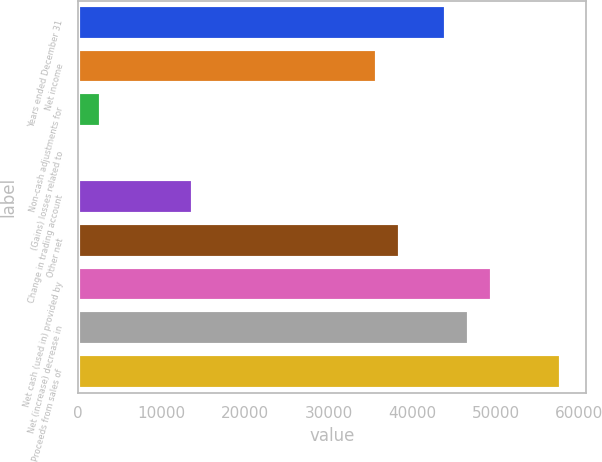Convert chart. <chart><loc_0><loc_0><loc_500><loc_500><bar_chart><fcel>Years ended December 31<fcel>Net income<fcel>Non-cash adjustments for<fcel>(Gains) losses related to<fcel>Change in trading account<fcel>Other net<fcel>Net cash (used in) provided by<fcel>Net (increase) decrease in<fcel>Proceeds from sales of<nl><fcel>44108.6<fcel>35843.3<fcel>2782.1<fcel>27<fcel>13802.5<fcel>38598.4<fcel>49618.8<fcel>46863.7<fcel>57884.1<nl></chart> 